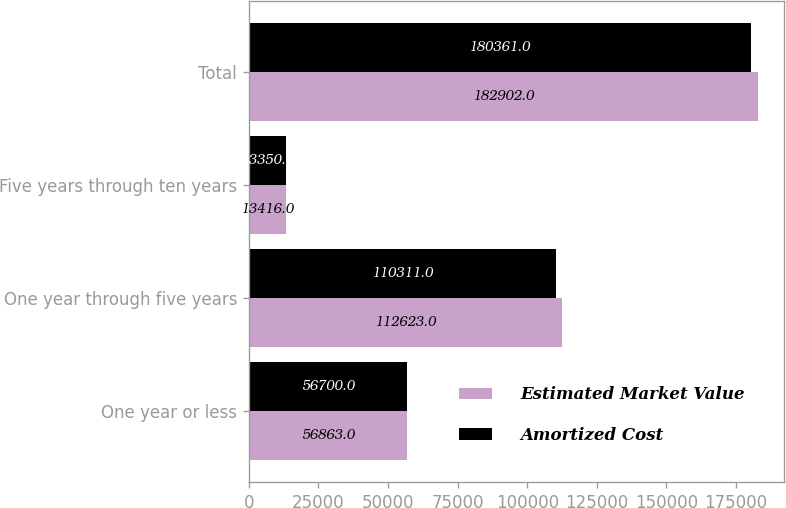Convert chart to OTSL. <chart><loc_0><loc_0><loc_500><loc_500><stacked_bar_chart><ecel><fcel>One year or less<fcel>One year through five years<fcel>Five years through ten years<fcel>Total<nl><fcel>Estimated Market Value<fcel>56863<fcel>112623<fcel>13416<fcel>182902<nl><fcel>Amortized Cost<fcel>56700<fcel>110311<fcel>13350<fcel>180361<nl></chart> 